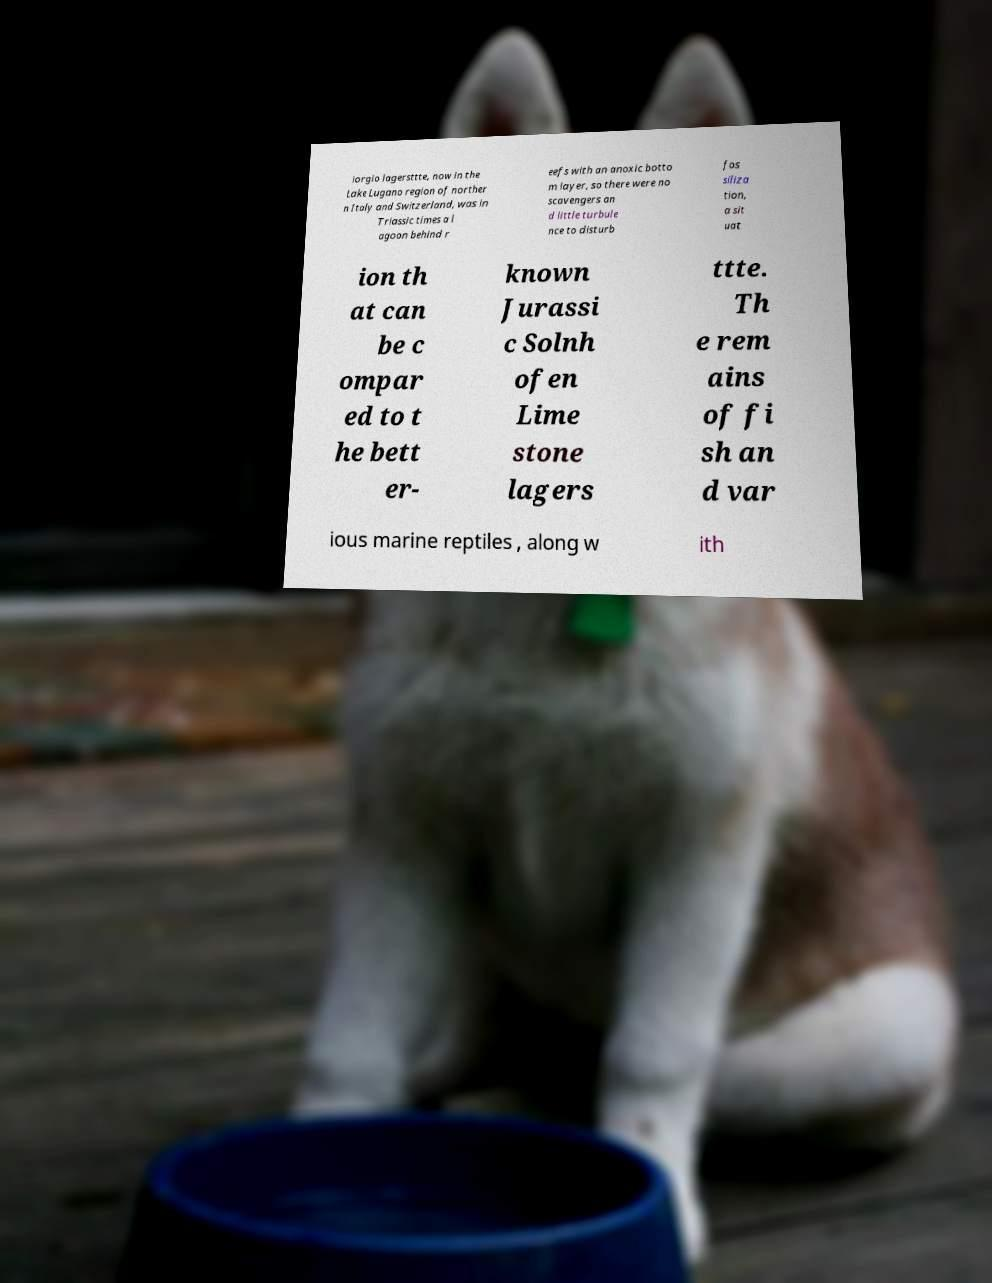Could you extract and type out the text from this image? iorgio lagersttte, now in the Lake Lugano region of norther n Italy and Switzerland, was in Triassic times a l agoon behind r eefs with an anoxic botto m layer, so there were no scavengers an d little turbule nce to disturb fos siliza tion, a sit uat ion th at can be c ompar ed to t he bett er- known Jurassi c Solnh ofen Lime stone lagers ttte. Th e rem ains of fi sh an d var ious marine reptiles , along w ith 